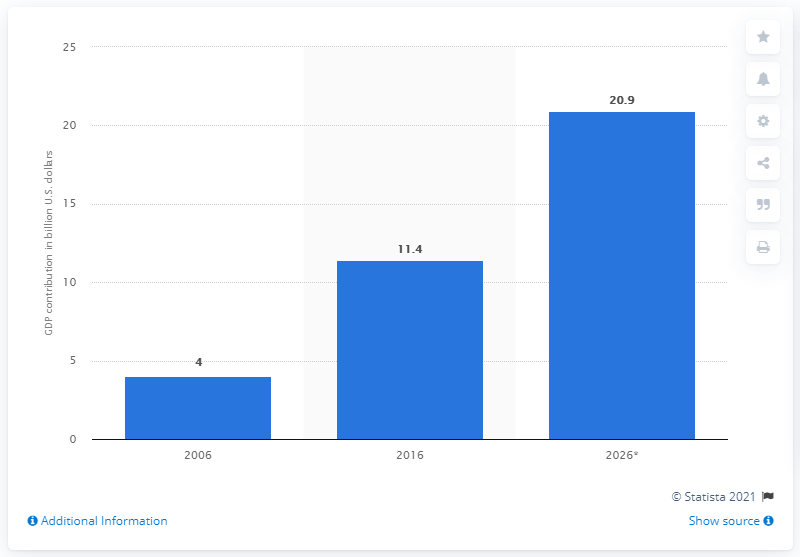Outline some significant characteristics in this image. According to estimates for the year 2026, Dubai's direct tourism contribution to the Gross Domestic Product of the United Arab Emirates was 20.9%. 